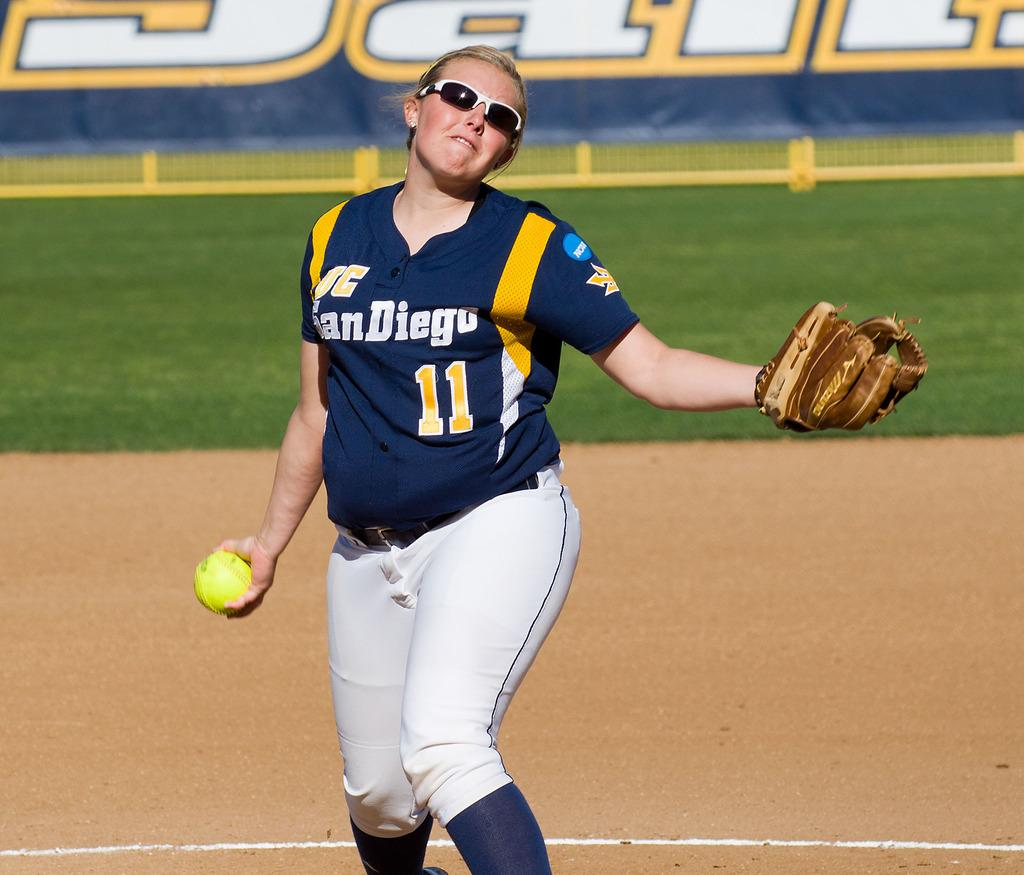<image>
Provide a brief description of the given image. A female sports player wearing a shirt reading san diego 11 